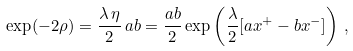Convert formula to latex. <formula><loc_0><loc_0><loc_500><loc_500>\exp ( - 2 \rho ) = \frac { \lambda \, \eta } { 2 } \, a b = \frac { a b } { 2 } \exp \left ( \frac { \lambda } { 2 } [ a x ^ { + } - b x ^ { - } ] \right ) \, ,</formula> 